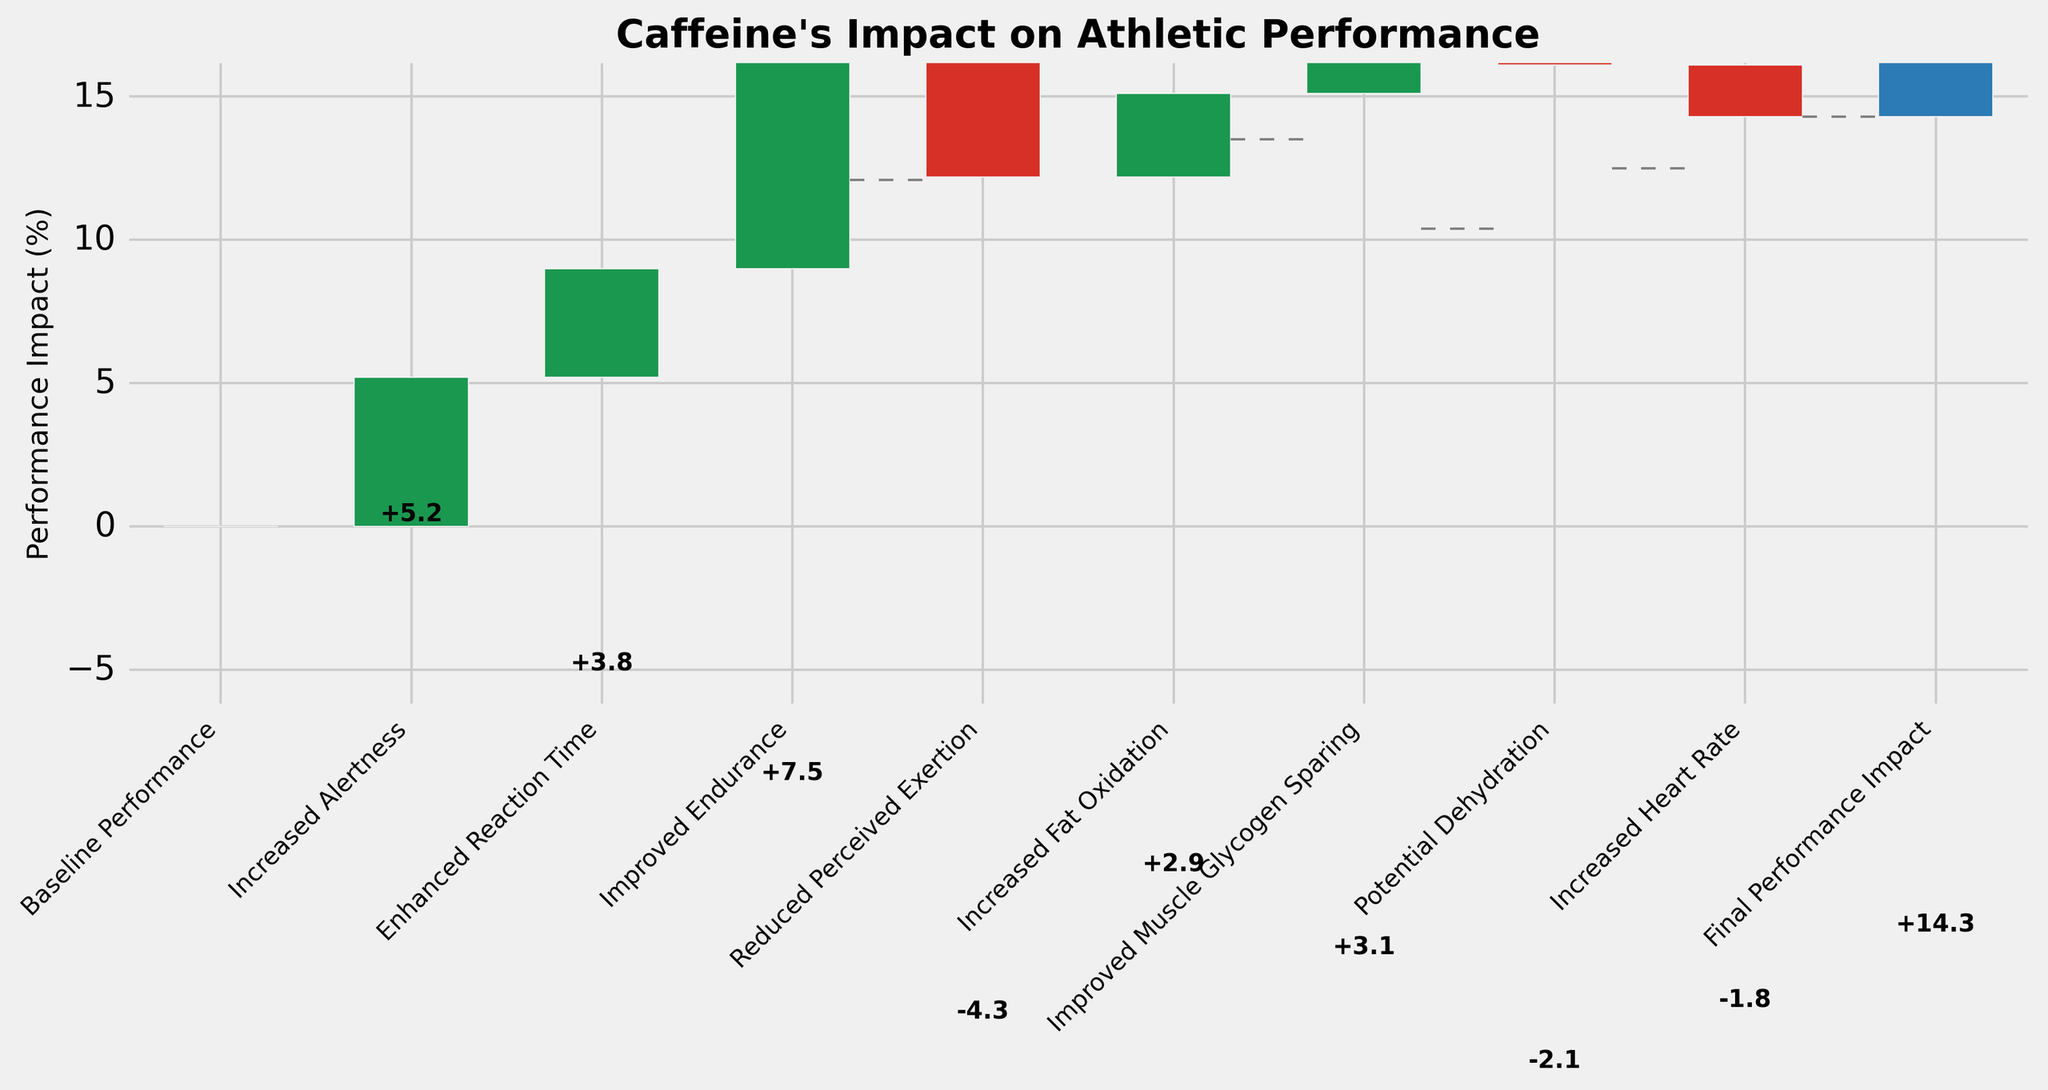What's the title of the chart? The title is located at the top of the chart. It provides a brief description of the overall data represented on the chart.
Answer: Caffeine's Impact on Athletic Performance What is the final performance impact percentage? The final performance impact is the sum of all impacts listed in the chart. It is shown at the end of the cumulative total.
Answer: 14.3% How does improved endurance compare to reduced perceived exertion? Improved endurance has a higher positive impact compared to the reduced perceived exertion's negative impact. Improved endurance increases performance by 7.5%, while reduced perceived exertion decreases it by 4.3%.
Answer: Improved endurance is greater than reduced perceived exertion Which category has the largest positive impact on performance? Look for the bar with the largest upward value. This indicates the greatest contribution to performance improvement.
Answer: Improved Endurance (+7.5%) What is the cumulative impact after the improved muscle glycogen sparing step? Start from the baseline, sequentially add and subtract the impacts up to the step before improved muscle glycogen sparing, and then add its impact.
Answer: 17.2% What are the two negative impacts of caffeine on athletic performance shown in the chart? Identify the categories with downward bars which indicate negative impacts on performance.
Answer: Potential Dehydration and Increased Heart Rate What is the difference in performance impact between increased alertness and increased fat oxidation? Subtract the impact of increased fat oxidation from increased alertness to find the difference.
Answer: 2.3% If you sum up the impact of increased alertness and enhanced reaction time, what is the combined impact? Add the impacts of increased alertness and enhanced reaction time together for the total.
Answer: 9.0% Which negative impact has a larger influence on performance: potential dehydration or increased heart rate? Compare the absolute values of the negative impacts to determine which has a greater magnitude.
Answer: Potential Dehydration By how much does reduced perceived exertion decrease performance? The value is shown as a negative impact on the chart, indicating a decrease in performance.
Answer: 4.3% 